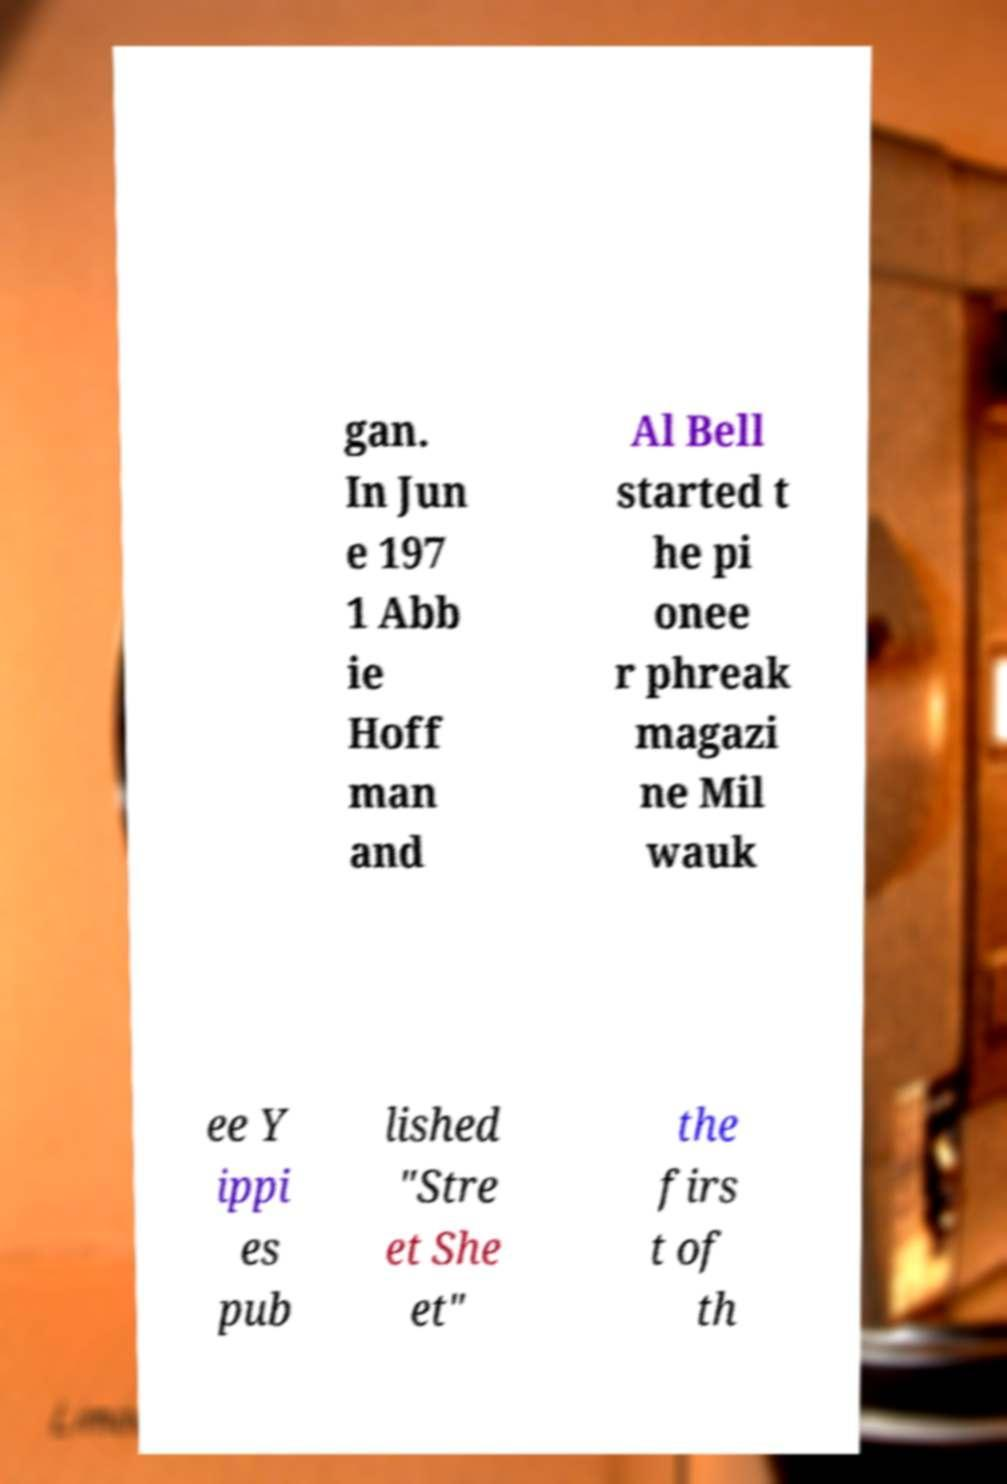Could you assist in decoding the text presented in this image and type it out clearly? gan. In Jun e 197 1 Abb ie Hoff man and Al Bell started t he pi onee r phreak magazi ne Mil wauk ee Y ippi es pub lished "Stre et She et" the firs t of th 